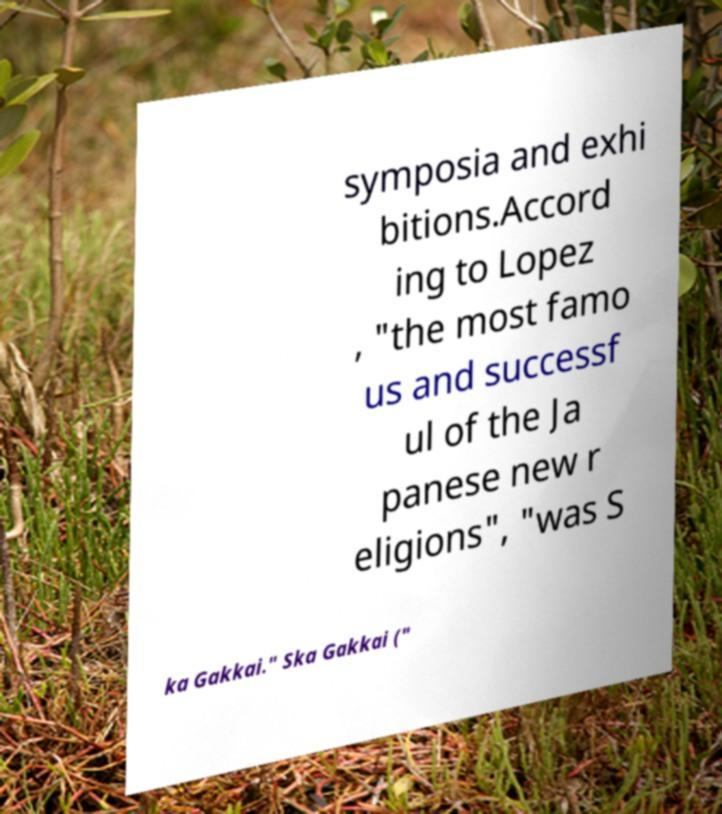Could you extract and type out the text from this image? symposia and exhi bitions.Accord ing to Lopez , "the most famo us and successf ul of the Ja panese new r eligions", "was S ka Gakkai." Ska Gakkai (" 